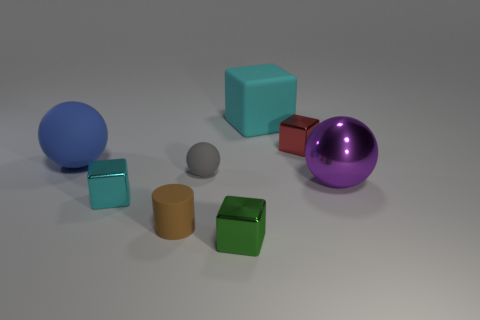Is the number of green shiny things less than the number of yellow matte spheres?
Your answer should be very brief. No. Is the color of the big rubber block the same as the metallic block that is on the left side of the tiny brown thing?
Make the answer very short. Yes. Are there an equal number of large rubber cubes in front of the matte cube and blue rubber things that are on the right side of the red metal block?
Your answer should be compact. Yes. What number of big cyan objects have the same shape as the small gray matte thing?
Your response must be concise. 0. Is there a big blue metal thing?
Make the answer very short. No. Does the big cyan block have the same material as the ball on the right side of the green block?
Your answer should be compact. No. There is a cylinder that is the same size as the green shiny object; what material is it?
Keep it short and to the point. Rubber. Are there any cyan things that have the same material as the small cyan block?
Offer a very short reply. No. There is a big ball on the left side of the small metal block behind the tiny cyan cube; are there any small green cubes that are left of it?
Your answer should be compact. No. The cyan rubber object that is the same size as the purple ball is what shape?
Offer a very short reply. Cube. 